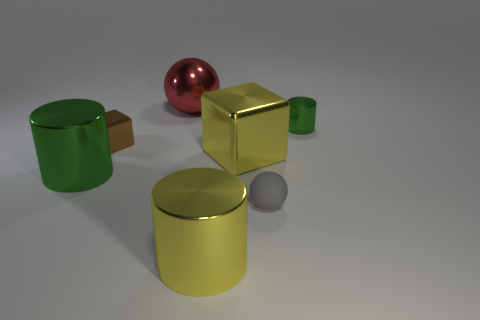Is there anything else that has the same material as the gray ball?
Give a very brief answer. No. Is there anything else that is the same color as the rubber sphere?
Offer a terse response. No. Is there a shiny sphere that is in front of the rubber ball that is behind the yellow cylinder on the left side of the matte ball?
Ensure brevity in your answer.  No. What size is the red sphere that is the same material as the big yellow cylinder?
Your response must be concise. Large. There is a tiny metal block; are there any small brown blocks to the right of it?
Your answer should be very brief. No. Are there any things that are to the left of the large cylinder behind the matte thing?
Offer a very short reply. No. Does the green thing that is to the left of the yellow cylinder have the same size as the ball to the left of the tiny matte thing?
Your response must be concise. Yes. What number of small things are brown cubes or green shiny objects?
Your answer should be compact. 2. What is the material of the small thing that is on the right side of the gray sphere that is in front of the small green thing?
Provide a succinct answer. Metal. What shape is the thing that is the same color as the big shiny cube?
Offer a very short reply. Cylinder. 